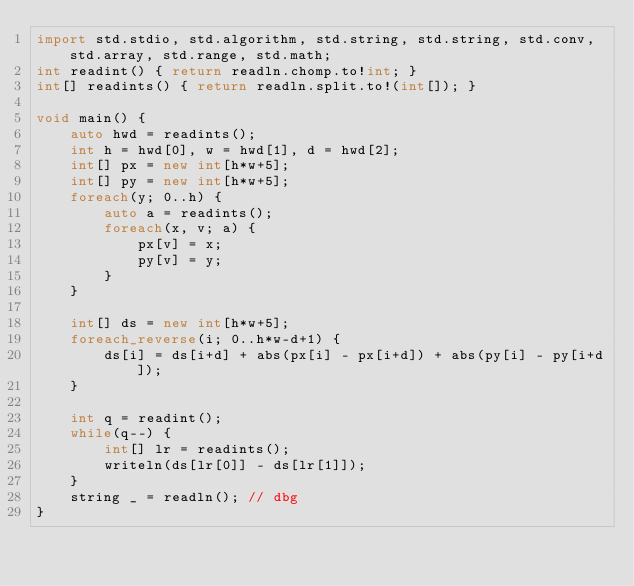Convert code to text. <code><loc_0><loc_0><loc_500><loc_500><_D_>import std.stdio, std.algorithm, std.string, std.string, std.conv, std.array, std.range, std.math;
int readint() { return readln.chomp.to!int; }
int[] readints() { return readln.split.to!(int[]); }

void main() {
    auto hwd = readints();
    int h = hwd[0], w = hwd[1], d = hwd[2];
    int[] px = new int[h*w+5];
    int[] py = new int[h*w+5];
    foreach(y; 0..h) {
        auto a = readints();
        foreach(x, v; a) {
            px[v] = x;
            py[v] = y;
        }
    }

    int[] ds = new int[h*w+5];
    foreach_reverse(i; 0..h*w-d+1) {
        ds[i] = ds[i+d] + abs(px[i] - px[i+d]) + abs(py[i] - py[i+d]);
    }
    
    int q = readint();
    while(q--) {
        int[] lr = readints();
        writeln(ds[lr[0]] - ds[lr[1]]);
    }
    string _ = readln(); // dbg
}</code> 